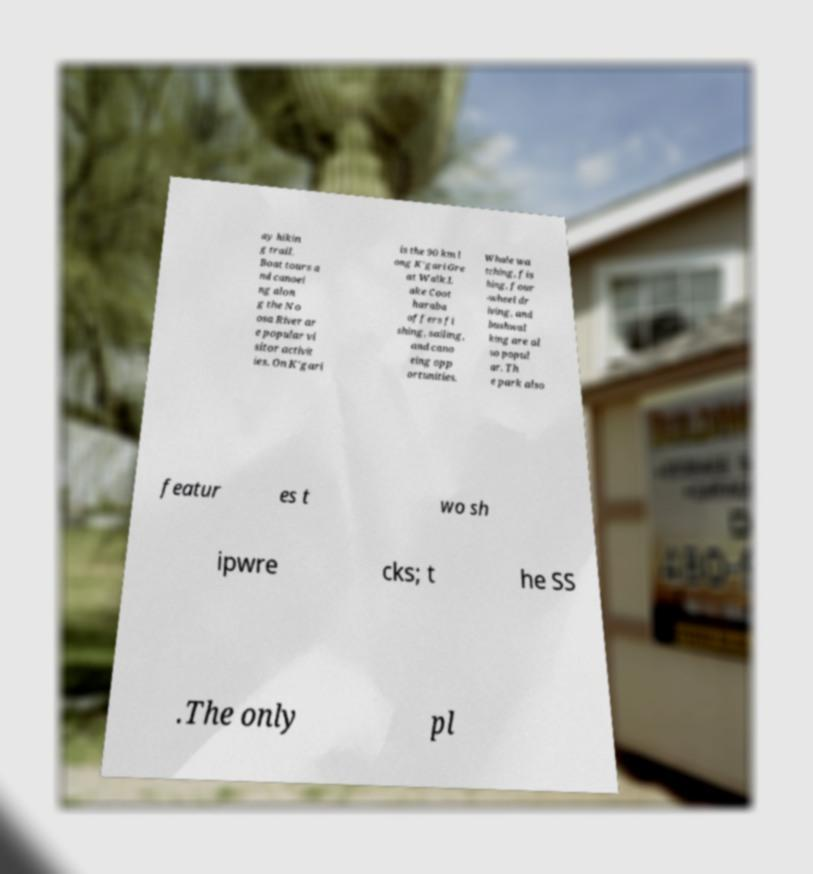There's text embedded in this image that I need extracted. Can you transcribe it verbatim? ay hikin g trail. Boat tours a nd canoei ng alon g the No osa River ar e popular vi sitor activit ies. On K'gari is the 90 km l ong K'gari Gre at Walk.L ake Coot haraba offers fi shing, sailing, and cano eing opp ortunities. Whale wa tching, fis hing, four -wheel dr iving, and bushwal king are al so popul ar. Th e park also featur es t wo sh ipwre cks; t he SS .The only pl 